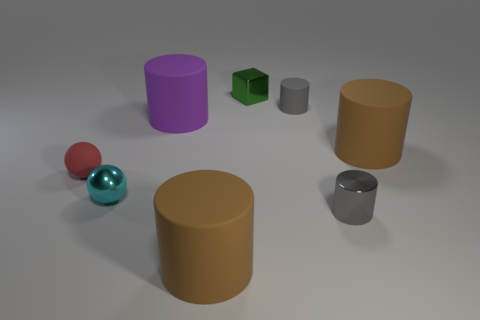Subtract all purple cylinders. How many cylinders are left? 4 Subtract all gray matte cylinders. How many cylinders are left? 4 Subtract all green cylinders. Subtract all cyan balls. How many cylinders are left? 5 Add 2 gray matte cylinders. How many objects exist? 10 Subtract all spheres. How many objects are left? 6 Add 2 big yellow metallic balls. How many big yellow metallic balls exist? 2 Subtract 0 green spheres. How many objects are left? 8 Subtract all big purple rubber cylinders. Subtract all big matte cylinders. How many objects are left? 4 Add 1 blocks. How many blocks are left? 2 